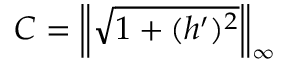Convert formula to latex. <formula><loc_0><loc_0><loc_500><loc_500>C = \left \| \sqrt { 1 + ( h ^ { \prime } ) ^ { 2 } } \right \| _ { \infty }</formula> 